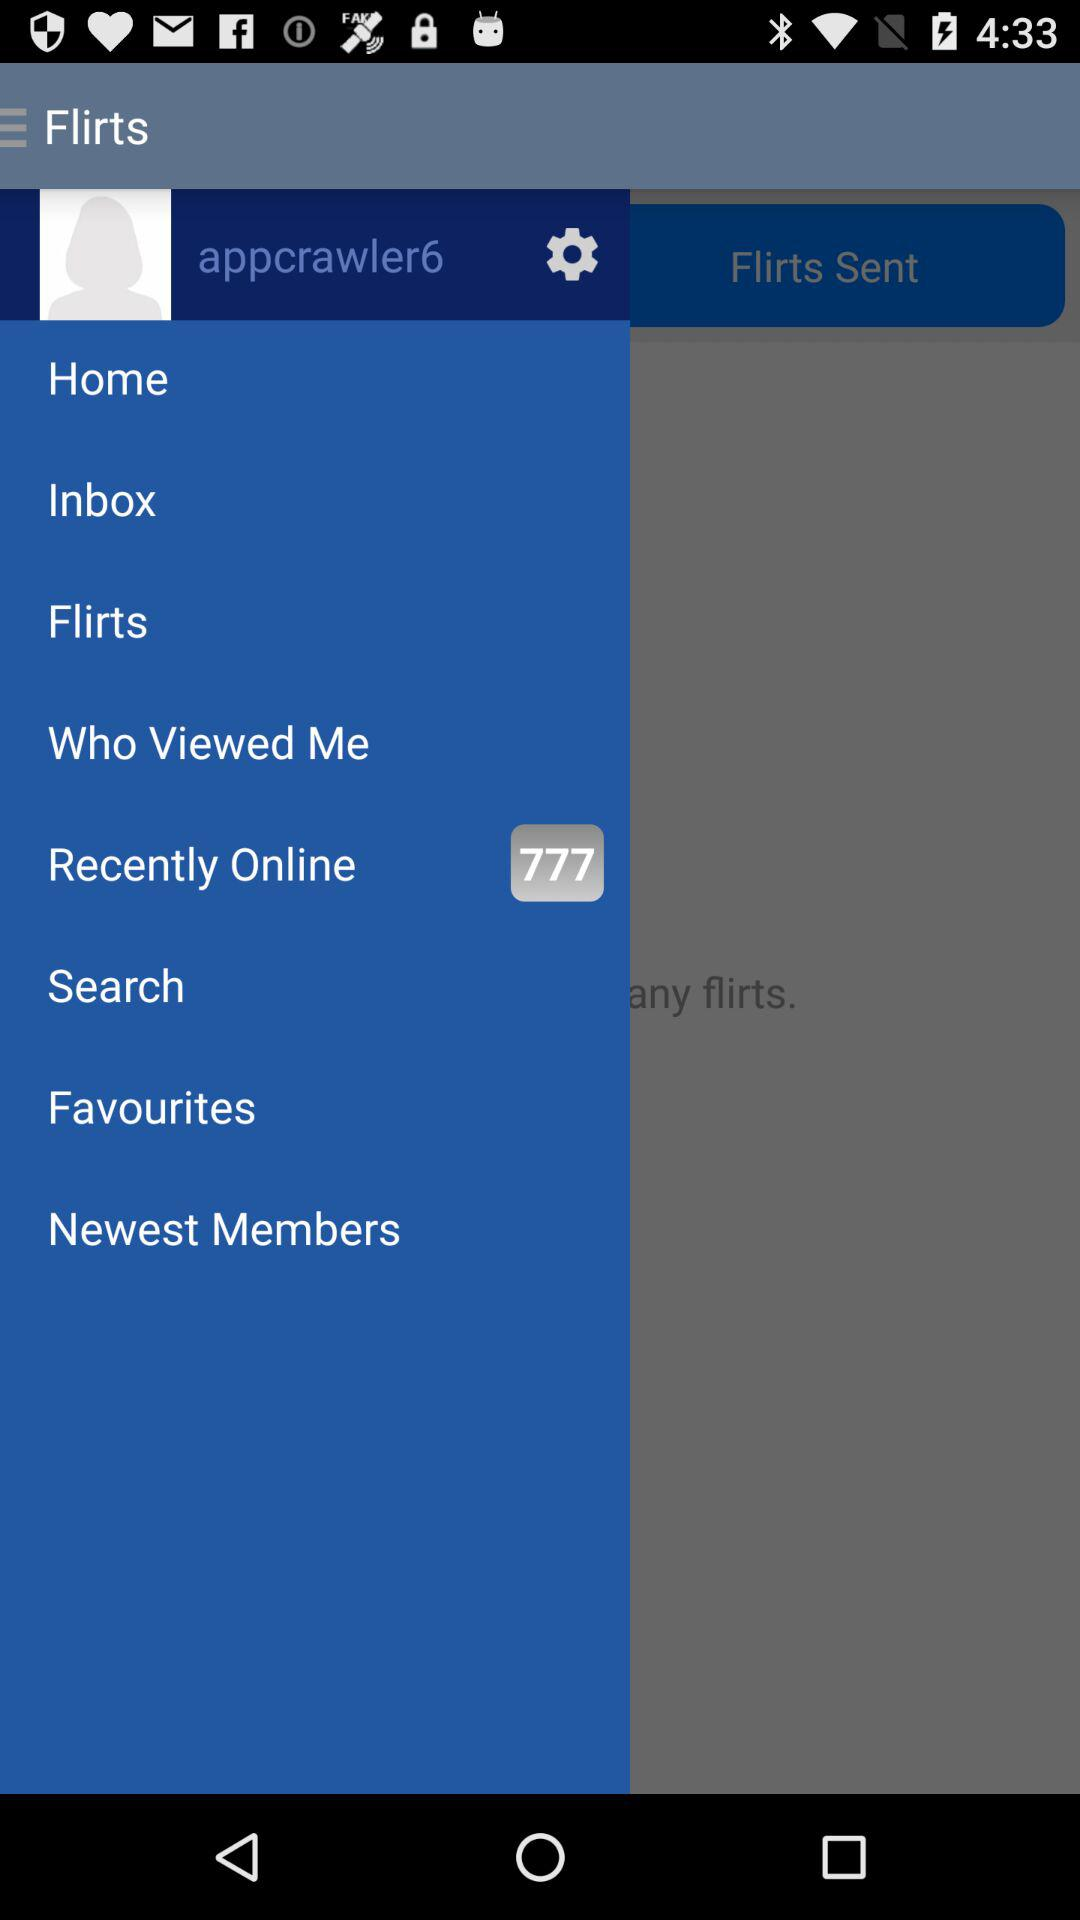How many recently online are there? There are 777 recently online. 